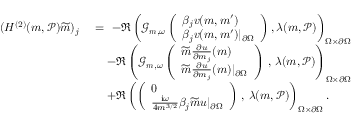Convert formula to latex. <formula><loc_0><loc_0><loc_500><loc_500>\begin{array} { r l } { ( H ^ { ( 2 ) } ( m , \mathcal { P } ) \widetilde { m } ) _ { j } \ } & { = \ - \Re \left ( \mathcal { G } _ { m , \omega } \left ( \begin{array} { l } { \beta _ { j } v ( m , m ^ { \prime } ) } \\ { \beta _ { j } v ( m , m ^ { \prime } ) | _ { \partial \Omega } } \end{array} \right ) , \lambda ( m , \mathcal { P } ) \right ) _ { \Omega \times \partial \Omega } } \\ & { \quad - \Re \left ( \mathcal { G } _ { m , \omega } \left ( \begin{array} { l } { \widetilde { m } \frac { \partial u } { \partial m _ { j } } ( m ) } \\ { \widetilde { m } \frac { \partial u } { \partial m _ { j } } ( m ) | _ { \partial \Omega } } \end{array} \right ) \, , \, \lambda ( m , \mathcal { P } ) \right ) _ { \Omega \times \partial \Omega } } \\ & { \quad + \Re \left ( \left ( \begin{array} { l } { 0 } \\ { \frac { i \omega } { 4 m ^ { 3 / 2 } } \beta _ { j } \widetilde { m } u | _ { \partial \Omega } } \end{array} \right ) \, , \, \lambda ( m , \mathcal { P } ) \right ) _ { \Omega \times \partial \Omega } . } \end{array}</formula> 